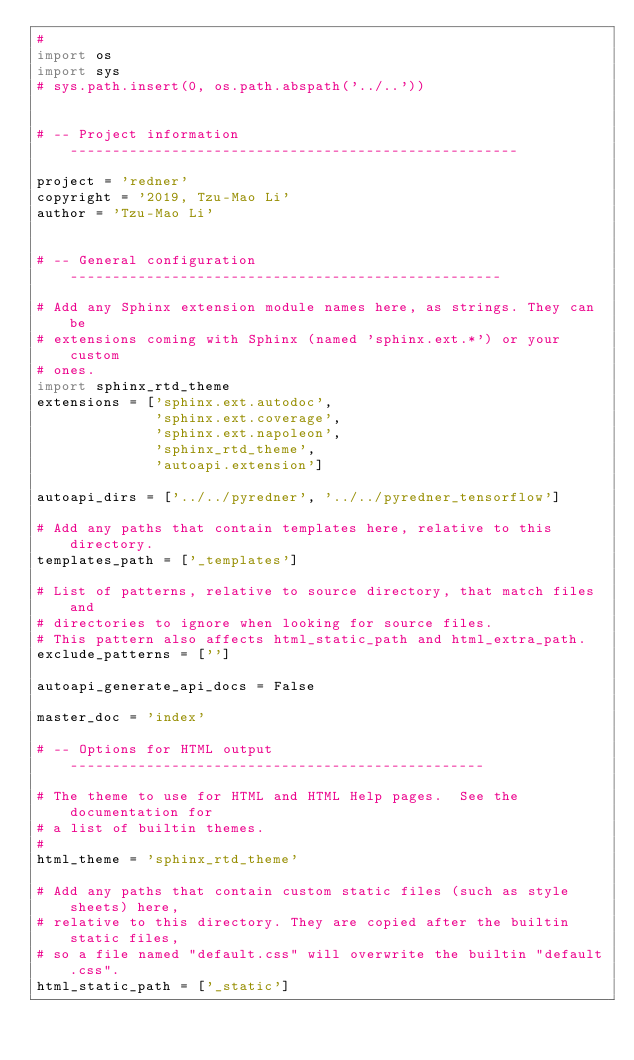Convert code to text. <code><loc_0><loc_0><loc_500><loc_500><_Python_>#
import os
import sys
# sys.path.insert(0, os.path.abspath('../..'))


# -- Project information -----------------------------------------------------

project = 'redner'
copyright = '2019, Tzu-Mao Li'
author = 'Tzu-Mao Li'


# -- General configuration ---------------------------------------------------

# Add any Sphinx extension module names here, as strings. They can be
# extensions coming with Sphinx (named 'sphinx.ext.*') or your custom
# ones.
import sphinx_rtd_theme
extensions = ['sphinx.ext.autodoc',
			  'sphinx.ext.coverage',
			  'sphinx.ext.napoleon',
			  'sphinx_rtd_theme',
			  'autoapi.extension']

autoapi_dirs = ['../../pyredner', '../../pyredner_tensorflow']

# Add any paths that contain templates here, relative to this directory.
templates_path = ['_templates']

# List of patterns, relative to source directory, that match files and
# directories to ignore when looking for source files.
# This pattern also affects html_static_path and html_extra_path.
exclude_patterns = ['']

autoapi_generate_api_docs = False

master_doc = 'index'

# -- Options for HTML output -------------------------------------------------

# The theme to use for HTML and HTML Help pages.  See the documentation for
# a list of builtin themes.
#
html_theme = 'sphinx_rtd_theme'

# Add any paths that contain custom static files (such as style sheets) here,
# relative to this directory. They are copied after the builtin static files,
# so a file named "default.css" will overwrite the builtin "default.css".
html_static_path = ['_static']
</code> 